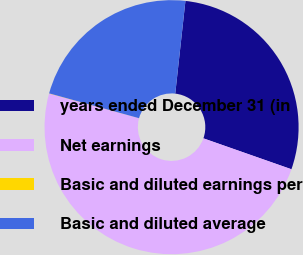<chart> <loc_0><loc_0><loc_500><loc_500><pie_chart><fcel>years ended December 31 (in<fcel>Net earnings<fcel>Basic and diluted earnings per<fcel>Basic and diluted average<nl><fcel>28.63%<fcel>48.88%<fcel>0.03%<fcel>22.45%<nl></chart> 